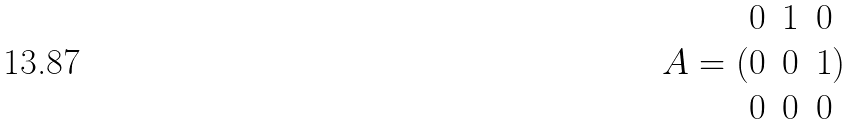Convert formula to latex. <formula><loc_0><loc_0><loc_500><loc_500>A = ( \begin{matrix} 0 & 1 & 0 \\ 0 & 0 & 1 \\ 0 & 0 & 0 \end{matrix} )</formula> 